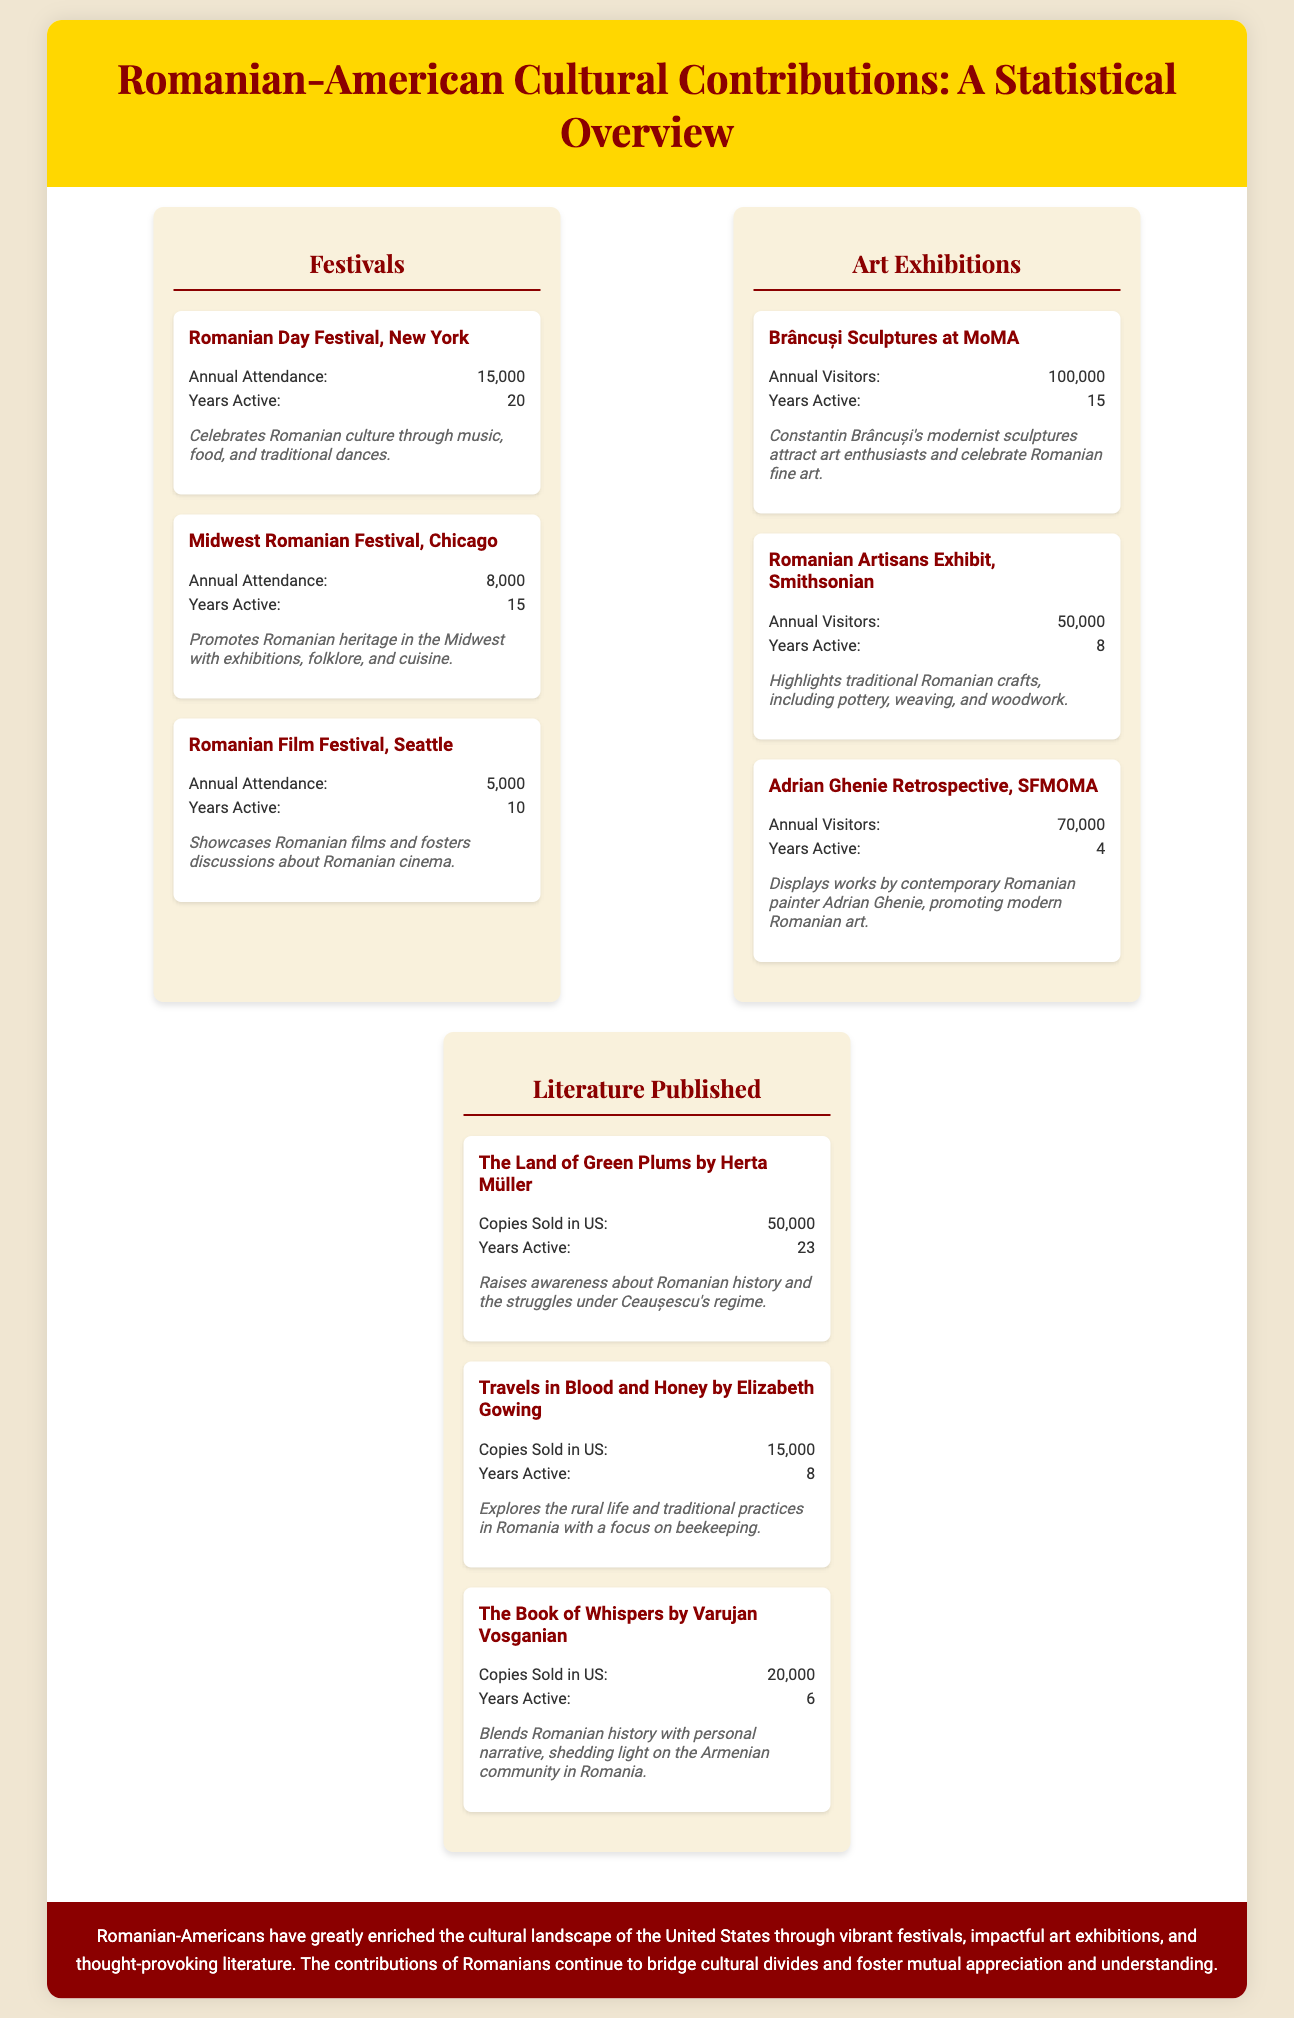What is the annual attendance of the Romanian Day Festival? The annual attendance is listed in the document under Festivals.
Answer: 15,000 How many years has the Midwest Romanian Festival been active? This information can be found in the section detailing the festivals.
Answer: 15 What is the annual visitor count for Brâncuși Sculptures at MoMA? This statistic is provided in the Art Exhibitions section.
Answer: 100,000 Who is the author of "The Land of Green Plums"? The author's name is presented in the Literature Published section of the infographic.
Answer: Herta Müller What impact does the Romanian Film Festival have? This can be inferred from the description of the festival's purpose in the document.
Answer: Showcases Romanian films Which exhibition has the highest annual visitor count? The annual visitor counts are compared among art exhibitions mentioned in the document.
Answer: Brâncuși Sculptures at MoMA What type of contributions are highlighted in the document? The document specifies the types of cultural contributions made by Romanian-Americans.
Answer: Festivals, Art Exhibitions, and Literature How many copies of "Travels in Blood and Honey" were sold in the U.S.? This data can be found under the Literature Published section of the document.
Answer: 15,000 What year is associated with the active status of Adrian Ghenie's retrospective? This information is included in the details of the contemporary art exhibition.
Answer: 4 What do Romanian festivals in the U.S. aim to promote? The impacts of the festivals can be interpreted from their descriptions in the document.
Answer: Romanian heritage 